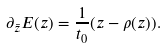Convert formula to latex. <formula><loc_0><loc_0><loc_500><loc_500>\partial _ { \bar { z } } E ( z ) = \frac { 1 } { t _ { 0 } } ( z - \rho ( z ) ) .</formula> 